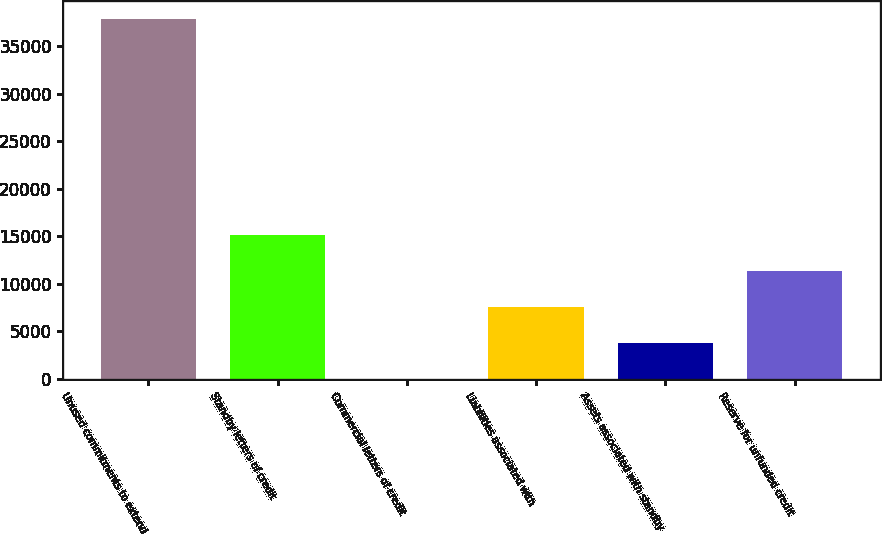<chart> <loc_0><loc_0><loc_500><loc_500><bar_chart><fcel>Unused commitments to extend<fcel>Standby letters of credit<fcel>Commercial letters of credit<fcel>Liabilities associated with<fcel>Assets associated with standby<fcel>Reserve for unfunded credit<nl><fcel>37872<fcel>15168.6<fcel>33<fcel>7600.8<fcel>3816.9<fcel>11384.7<nl></chart> 